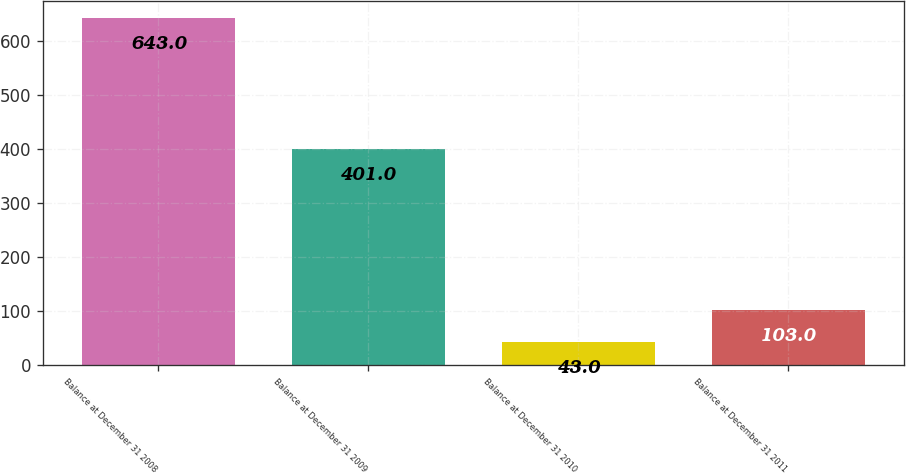Convert chart. <chart><loc_0><loc_0><loc_500><loc_500><bar_chart><fcel>Balance at December 31 2008<fcel>Balance at December 31 2009<fcel>Balance at December 31 2010<fcel>Balance at December 31 2011<nl><fcel>643<fcel>401<fcel>43<fcel>103<nl></chart> 